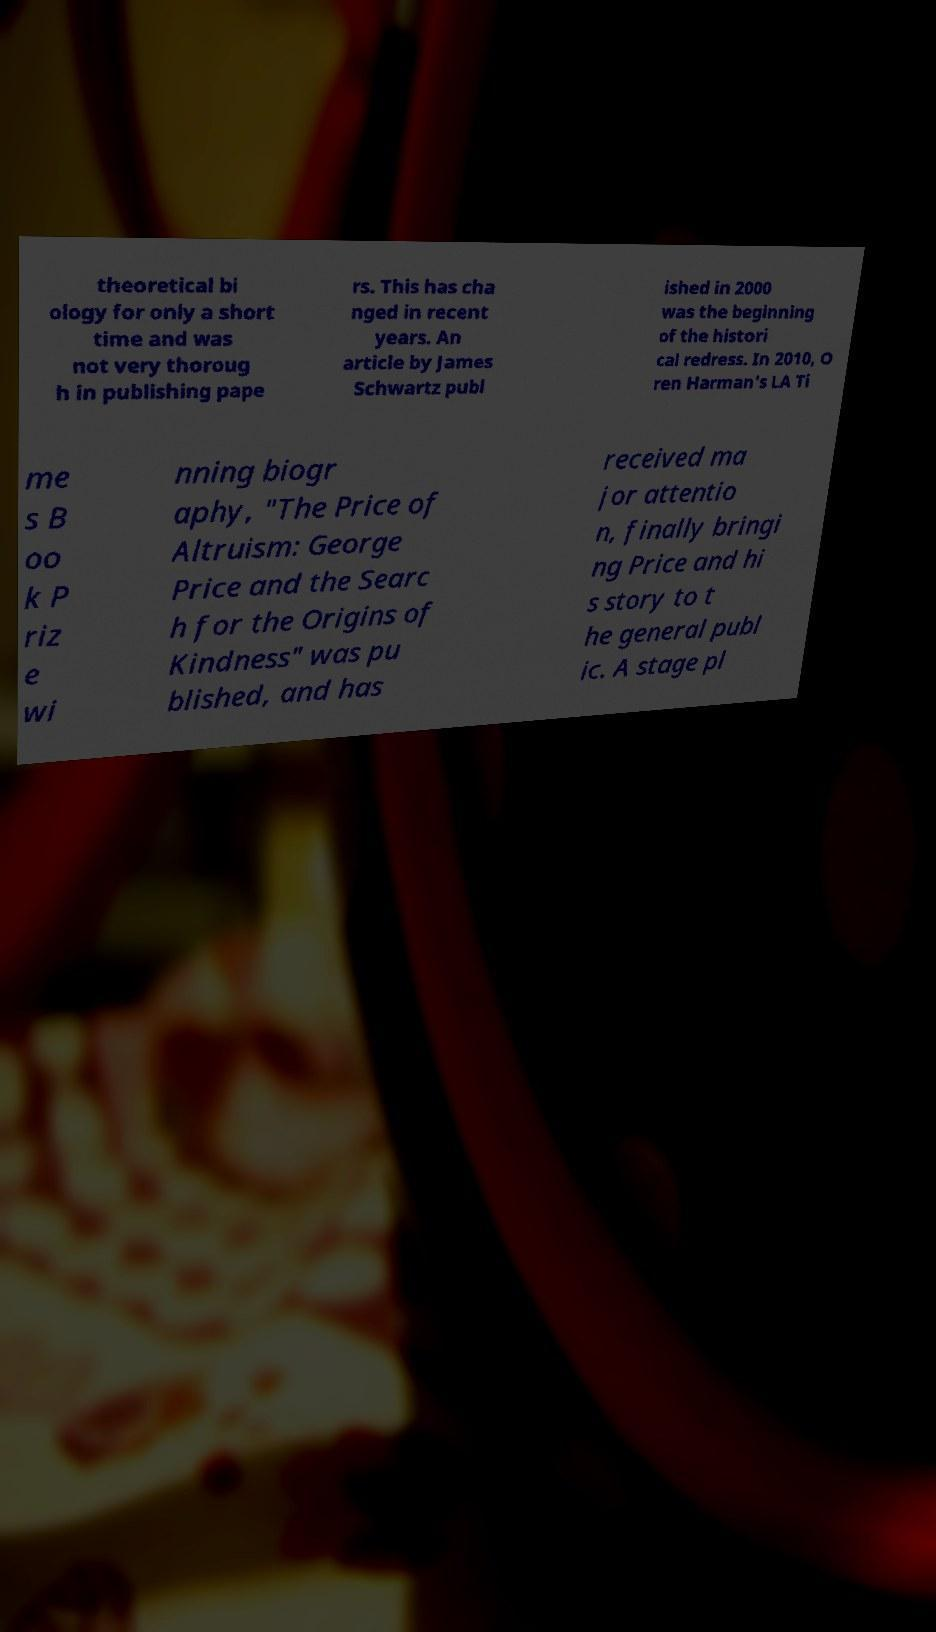I need the written content from this picture converted into text. Can you do that? theoretical bi ology for only a short time and was not very thoroug h in publishing pape rs. This has cha nged in recent years. An article by James Schwartz publ ished in 2000 was the beginning of the histori cal redress. In 2010, O ren Harman's LA Ti me s B oo k P riz e wi nning biogr aphy, "The Price of Altruism: George Price and the Searc h for the Origins of Kindness" was pu blished, and has received ma jor attentio n, finally bringi ng Price and hi s story to t he general publ ic. A stage pl 